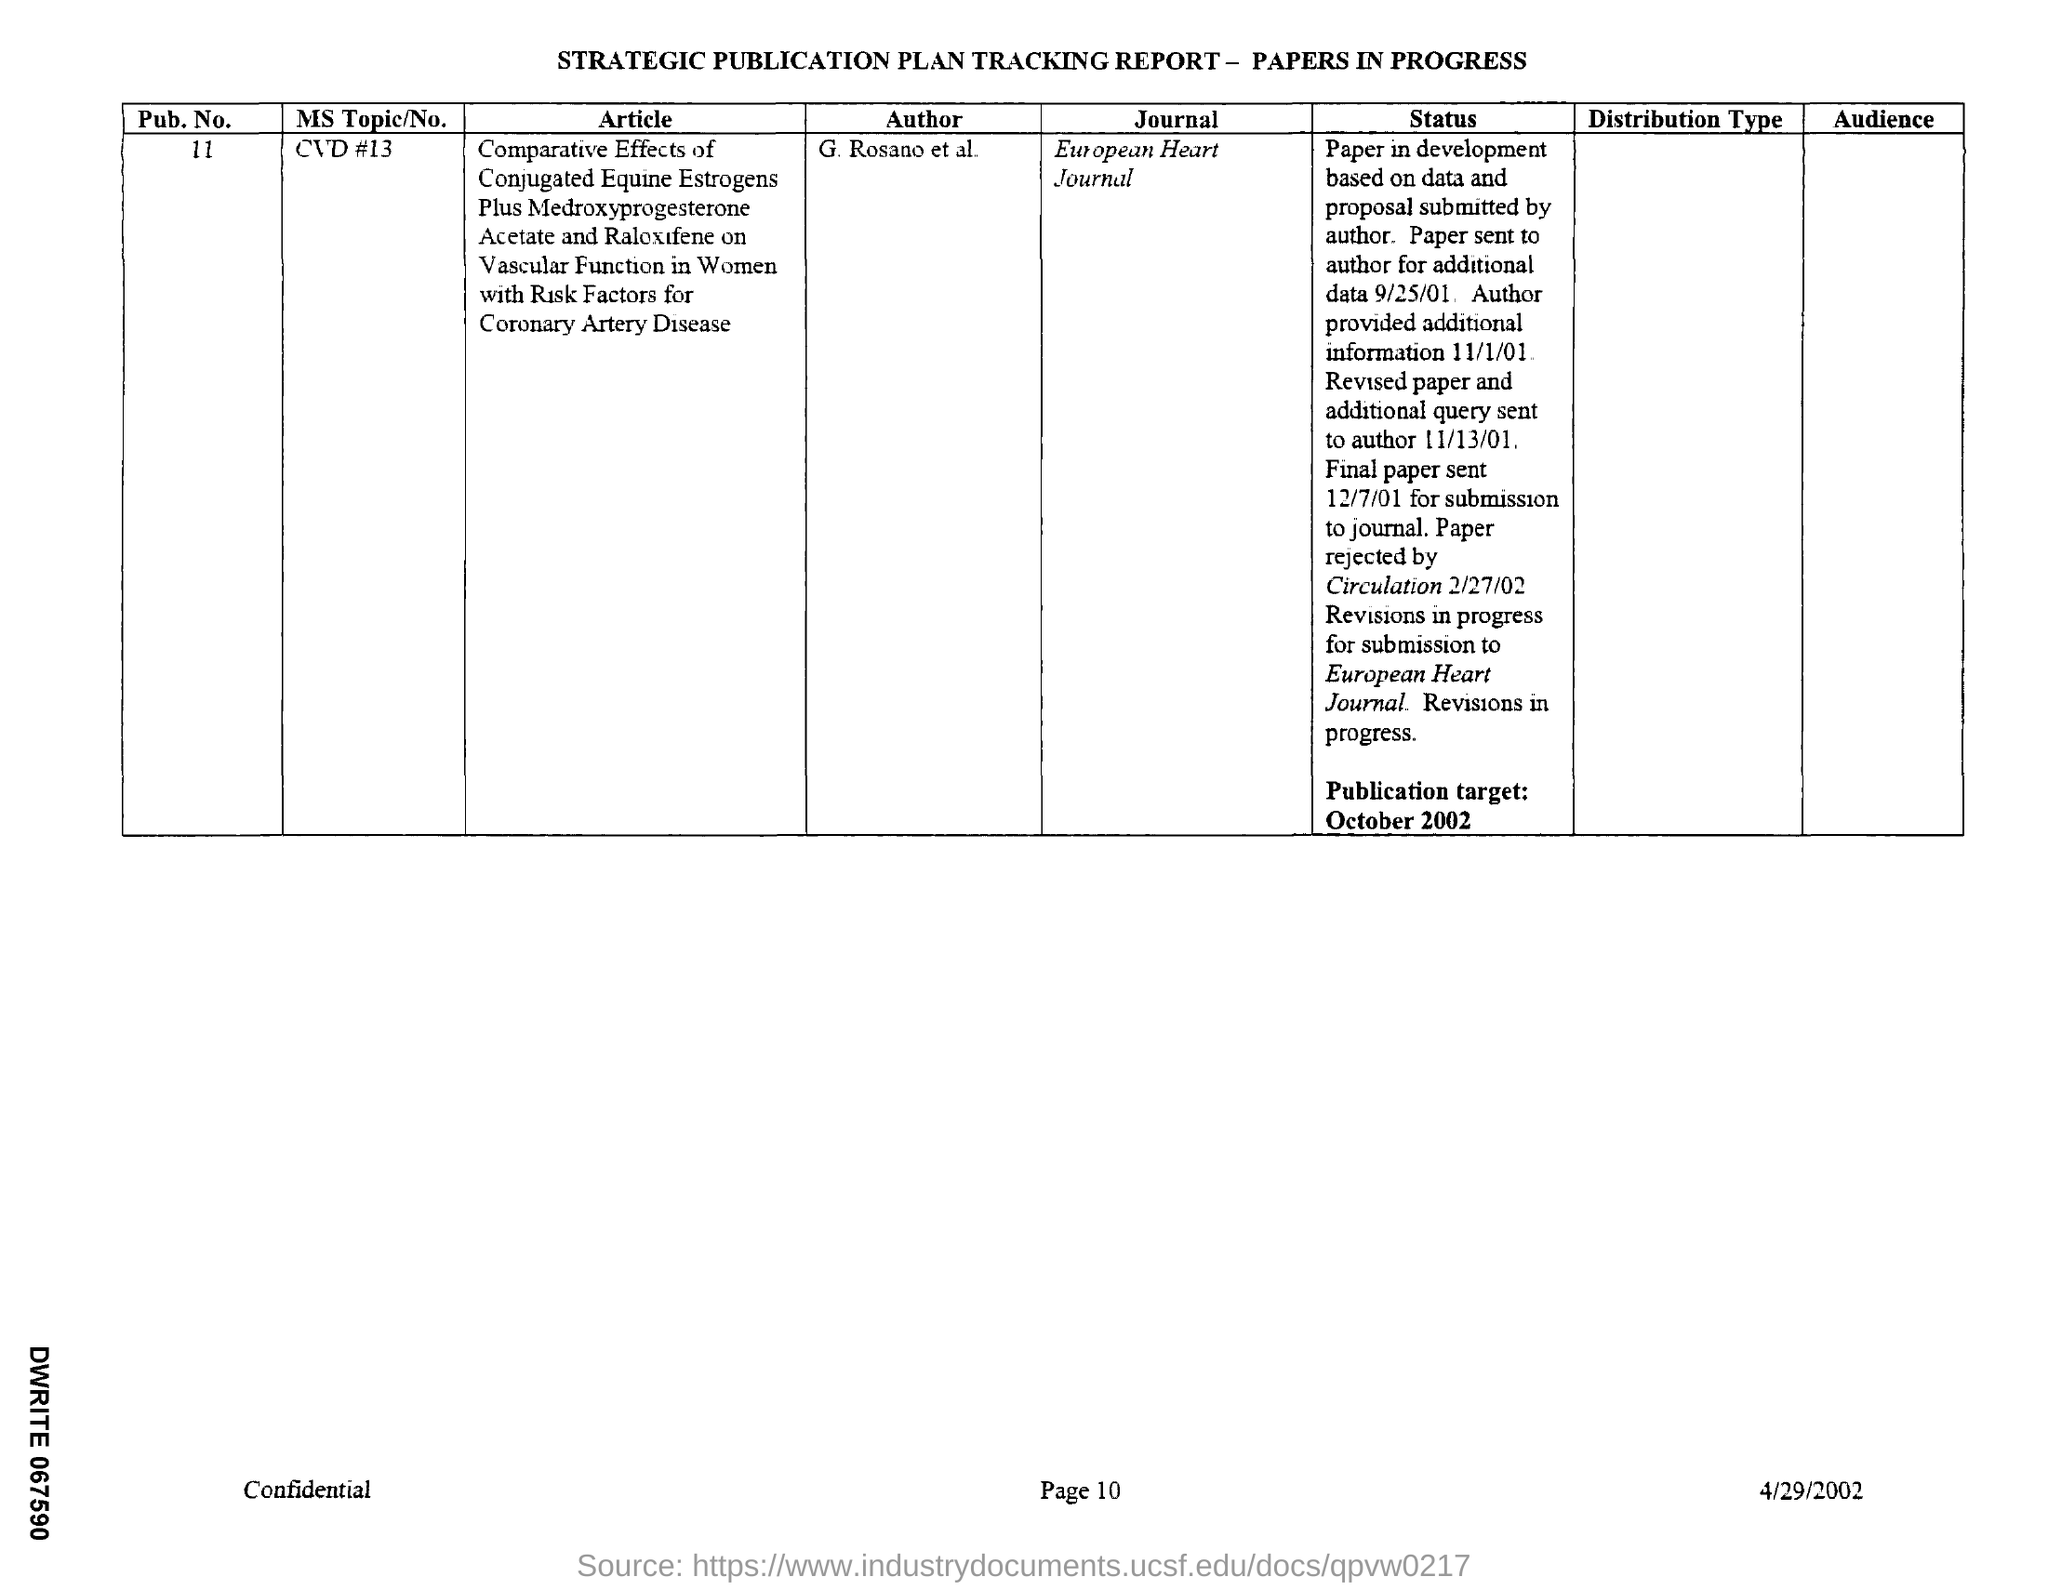List a handful of essential elements in this visual. The paper will be published in the European Heart Journal. The author of the article is G. Rosano, along with other individuals who are listed in the text as "et al. Please provide the publication number, 11.. The document is dated April 29, 2002. The publication target is October 2002. 